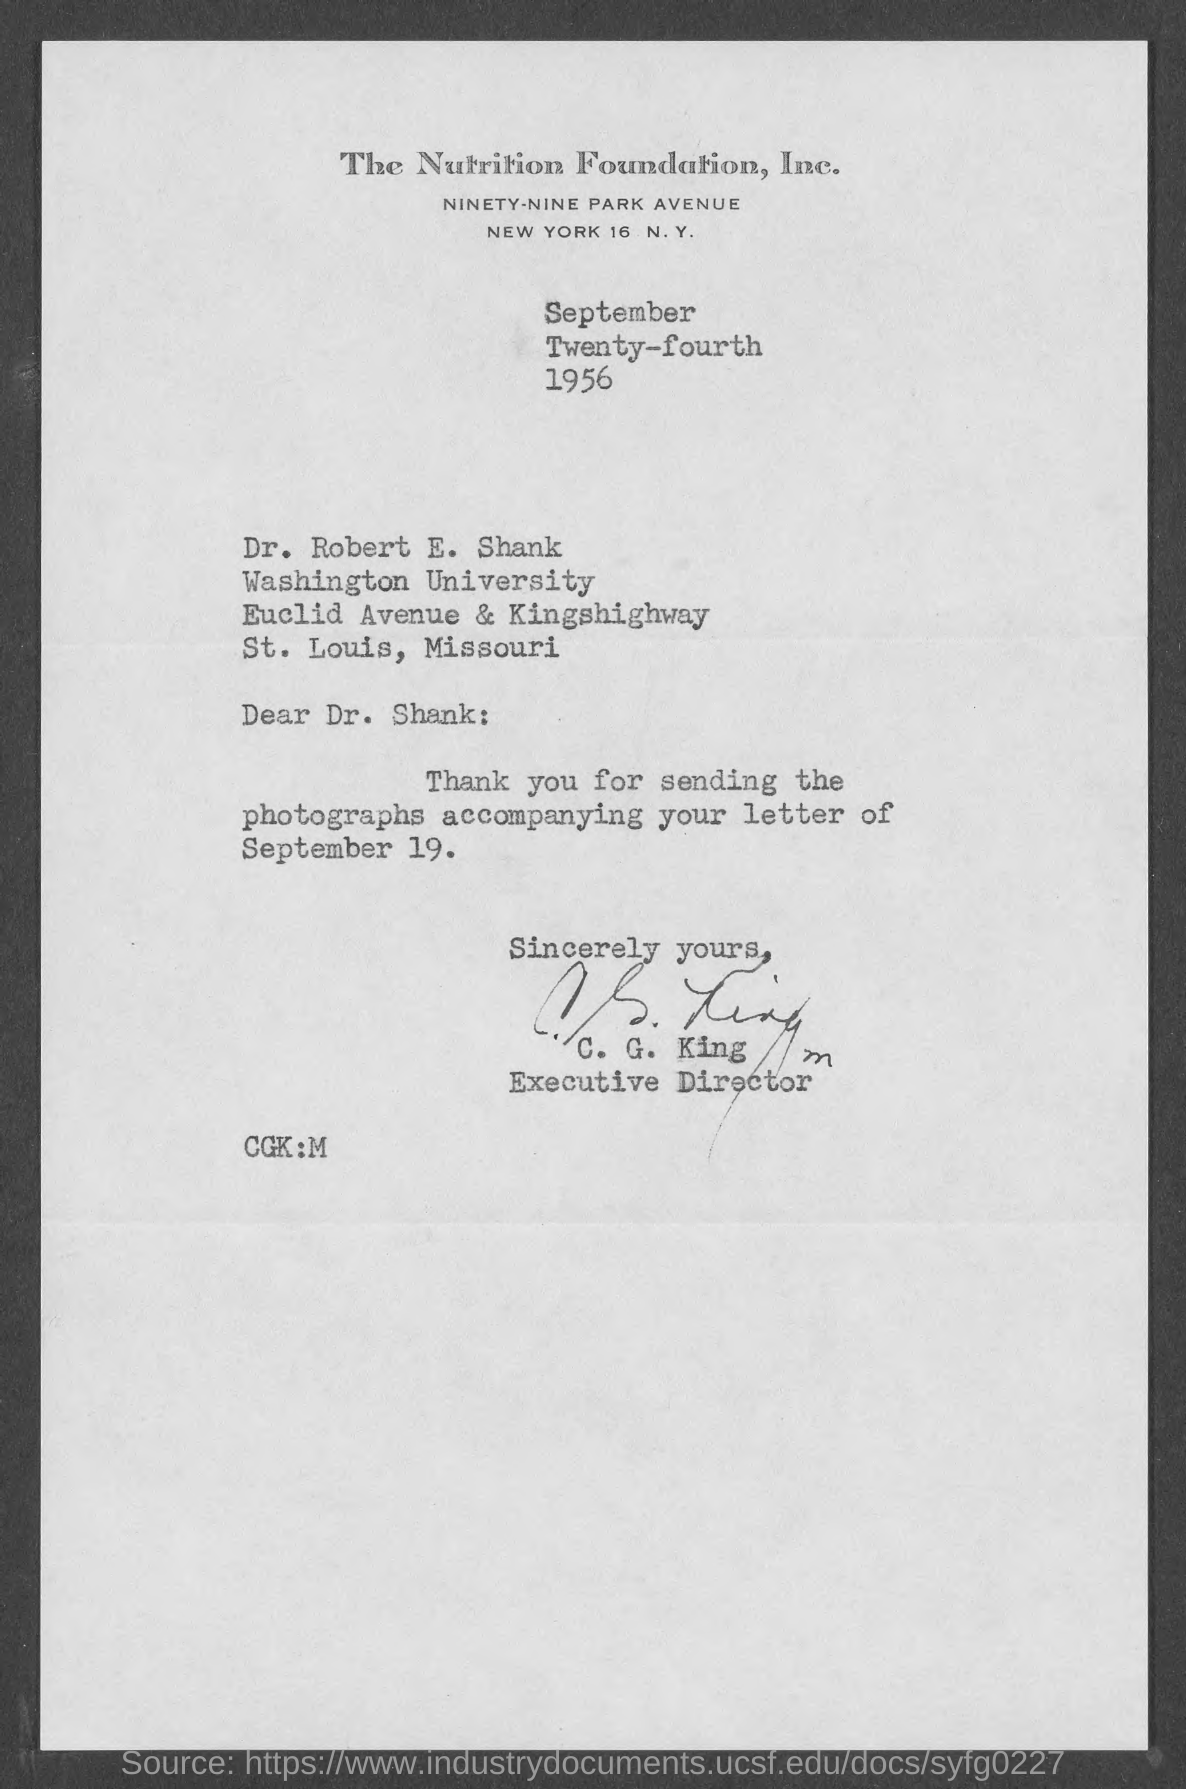What is the date on the document?
Ensure brevity in your answer.  September Twenty-fourth 1956. To Whom is this letter addressed to?
Offer a terse response. Dr. Robert E. Shank. What is accompanying the letter of September 19?
Ensure brevity in your answer.  Photographs. 